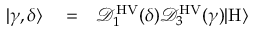<formula> <loc_0><loc_0><loc_500><loc_500>\begin{array} { r l r } { | \gamma , \delta \rangle } & = } & { \mathcal { D } _ { 1 } ^ { H V } ( \delta ) \mathcal { D } _ { 3 } ^ { H V } ( \gamma ) | H \rangle } \end{array}</formula> 